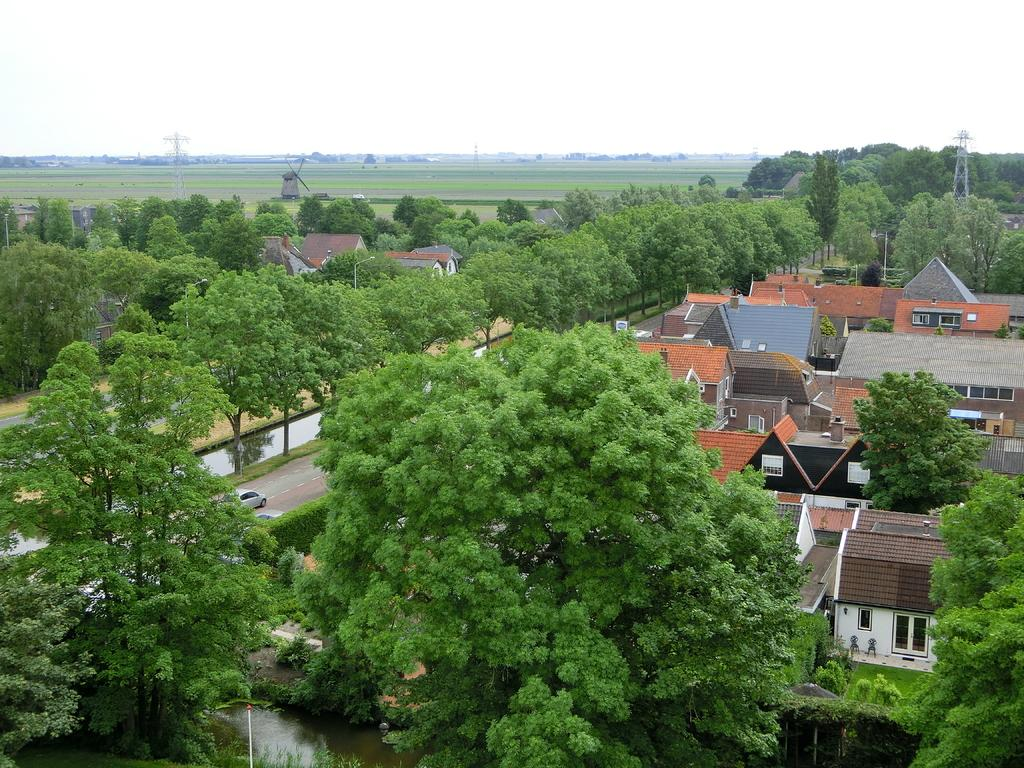What type of buildings can be seen in the image? There are houses in the image. What other natural elements are present in the image? There are trees in the image. What mode of transportation can be seen on the road in the image? There are cars on the road in the image. What structures can be seen in the background of the image? There are towers and a windmill in the background of the image. What type of account is being discussed on the stage in the image? There is no stage or account mentioned in the image. 